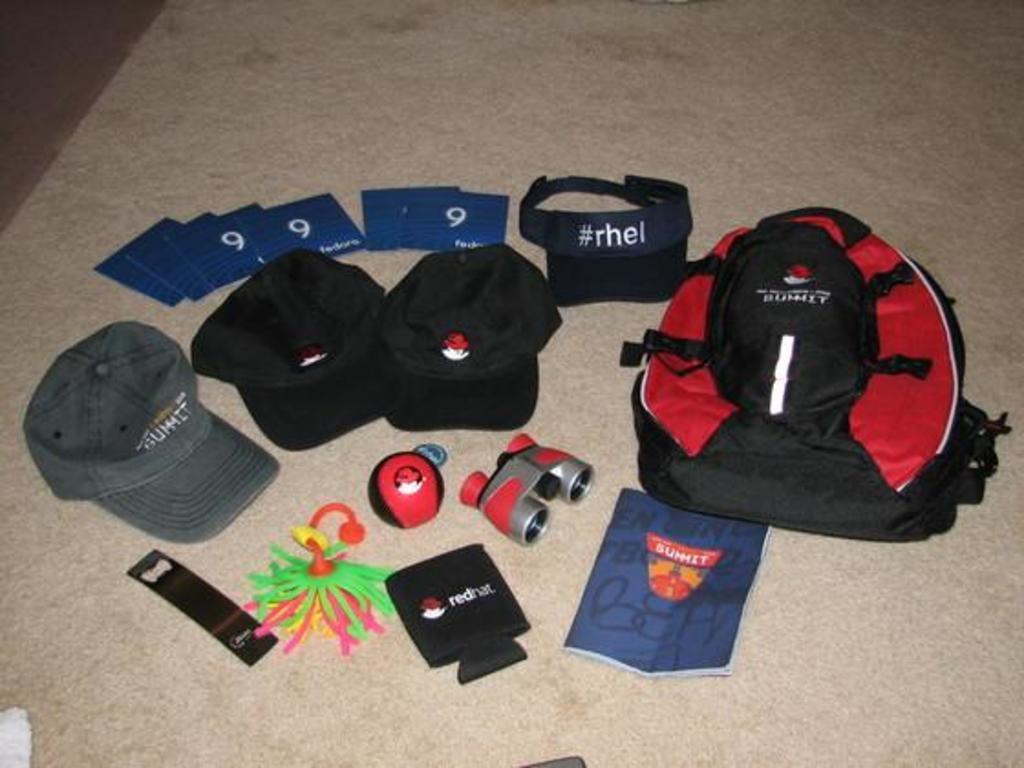Describe this image in one or two sentences. In this image i can see a bag, cap, a paper, a ball, cards on a floor. 